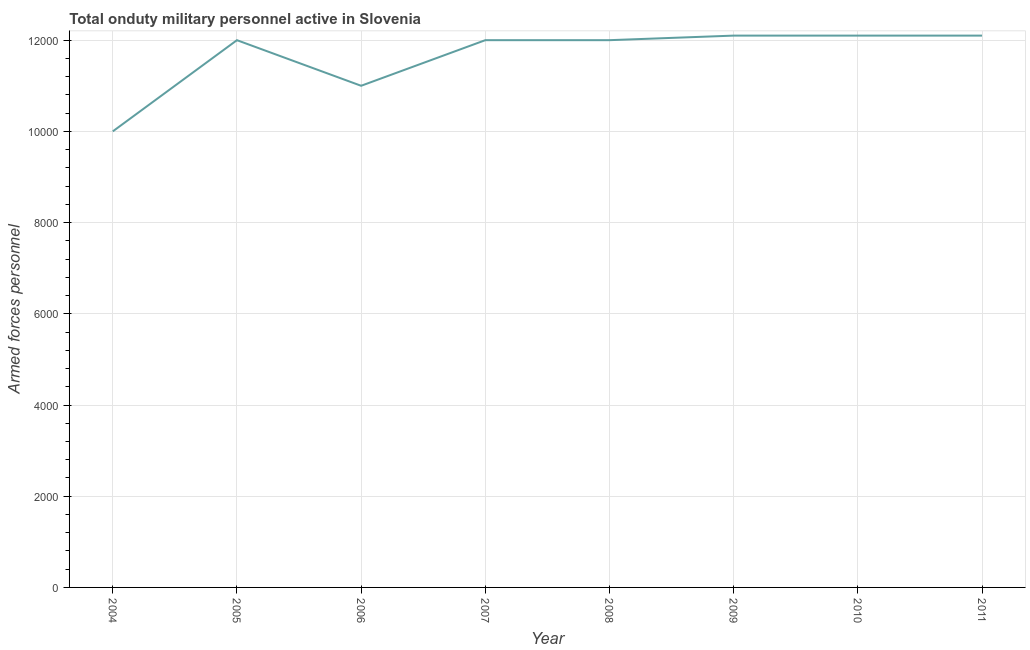What is the number of armed forces personnel in 2010?
Make the answer very short. 1.21e+04. Across all years, what is the maximum number of armed forces personnel?
Offer a very short reply. 1.21e+04. Across all years, what is the minimum number of armed forces personnel?
Provide a succinct answer. 10000. What is the sum of the number of armed forces personnel?
Make the answer very short. 9.33e+04. What is the difference between the number of armed forces personnel in 2005 and 2010?
Keep it short and to the point. -100. What is the average number of armed forces personnel per year?
Ensure brevity in your answer.  1.17e+04. What is the median number of armed forces personnel?
Your answer should be very brief. 1.20e+04. In how many years, is the number of armed forces personnel greater than 800 ?
Provide a short and direct response. 8. Do a majority of the years between 2007 and 2008 (inclusive) have number of armed forces personnel greater than 11600 ?
Keep it short and to the point. Yes. What is the ratio of the number of armed forces personnel in 2007 to that in 2009?
Your response must be concise. 0.99. What is the difference between the highest and the second highest number of armed forces personnel?
Ensure brevity in your answer.  0. Is the sum of the number of armed forces personnel in 2006 and 2011 greater than the maximum number of armed forces personnel across all years?
Your answer should be compact. Yes. What is the difference between the highest and the lowest number of armed forces personnel?
Ensure brevity in your answer.  2100. Does the number of armed forces personnel monotonically increase over the years?
Provide a short and direct response. No. How many lines are there?
Your answer should be compact. 1. What is the difference between two consecutive major ticks on the Y-axis?
Make the answer very short. 2000. Are the values on the major ticks of Y-axis written in scientific E-notation?
Make the answer very short. No. What is the title of the graph?
Your response must be concise. Total onduty military personnel active in Slovenia. What is the label or title of the X-axis?
Provide a succinct answer. Year. What is the label or title of the Y-axis?
Ensure brevity in your answer.  Armed forces personnel. What is the Armed forces personnel in 2005?
Make the answer very short. 1.20e+04. What is the Armed forces personnel of 2006?
Offer a terse response. 1.10e+04. What is the Armed forces personnel in 2007?
Keep it short and to the point. 1.20e+04. What is the Armed forces personnel of 2008?
Offer a terse response. 1.20e+04. What is the Armed forces personnel of 2009?
Your answer should be compact. 1.21e+04. What is the Armed forces personnel in 2010?
Your answer should be compact. 1.21e+04. What is the Armed forces personnel of 2011?
Give a very brief answer. 1.21e+04. What is the difference between the Armed forces personnel in 2004 and 2005?
Offer a very short reply. -2000. What is the difference between the Armed forces personnel in 2004 and 2006?
Give a very brief answer. -1000. What is the difference between the Armed forces personnel in 2004 and 2007?
Give a very brief answer. -2000. What is the difference between the Armed forces personnel in 2004 and 2008?
Provide a short and direct response. -2000. What is the difference between the Armed forces personnel in 2004 and 2009?
Your answer should be compact. -2100. What is the difference between the Armed forces personnel in 2004 and 2010?
Make the answer very short. -2100. What is the difference between the Armed forces personnel in 2004 and 2011?
Ensure brevity in your answer.  -2100. What is the difference between the Armed forces personnel in 2005 and 2008?
Offer a very short reply. 0. What is the difference between the Armed forces personnel in 2005 and 2009?
Your answer should be very brief. -100. What is the difference between the Armed forces personnel in 2005 and 2010?
Your answer should be compact. -100. What is the difference between the Armed forces personnel in 2005 and 2011?
Provide a succinct answer. -100. What is the difference between the Armed forces personnel in 2006 and 2007?
Offer a very short reply. -1000. What is the difference between the Armed forces personnel in 2006 and 2008?
Ensure brevity in your answer.  -1000. What is the difference between the Armed forces personnel in 2006 and 2009?
Give a very brief answer. -1100. What is the difference between the Armed forces personnel in 2006 and 2010?
Your response must be concise. -1100. What is the difference between the Armed forces personnel in 2006 and 2011?
Your answer should be compact. -1100. What is the difference between the Armed forces personnel in 2007 and 2009?
Offer a very short reply. -100. What is the difference between the Armed forces personnel in 2007 and 2010?
Offer a very short reply. -100. What is the difference between the Armed forces personnel in 2007 and 2011?
Your answer should be compact. -100. What is the difference between the Armed forces personnel in 2008 and 2009?
Provide a succinct answer. -100. What is the difference between the Armed forces personnel in 2008 and 2010?
Your answer should be compact. -100. What is the difference between the Armed forces personnel in 2008 and 2011?
Keep it short and to the point. -100. What is the difference between the Armed forces personnel in 2009 and 2010?
Offer a terse response. 0. What is the difference between the Armed forces personnel in 2009 and 2011?
Provide a succinct answer. 0. What is the difference between the Armed forces personnel in 2010 and 2011?
Provide a short and direct response. 0. What is the ratio of the Armed forces personnel in 2004 to that in 2005?
Keep it short and to the point. 0.83. What is the ratio of the Armed forces personnel in 2004 to that in 2006?
Offer a very short reply. 0.91. What is the ratio of the Armed forces personnel in 2004 to that in 2007?
Your answer should be very brief. 0.83. What is the ratio of the Armed forces personnel in 2004 to that in 2008?
Keep it short and to the point. 0.83. What is the ratio of the Armed forces personnel in 2004 to that in 2009?
Provide a succinct answer. 0.83. What is the ratio of the Armed forces personnel in 2004 to that in 2010?
Provide a succinct answer. 0.83. What is the ratio of the Armed forces personnel in 2004 to that in 2011?
Offer a terse response. 0.83. What is the ratio of the Armed forces personnel in 2005 to that in 2006?
Offer a terse response. 1.09. What is the ratio of the Armed forces personnel in 2005 to that in 2007?
Your response must be concise. 1. What is the ratio of the Armed forces personnel in 2005 to that in 2011?
Your answer should be very brief. 0.99. What is the ratio of the Armed forces personnel in 2006 to that in 2007?
Offer a very short reply. 0.92. What is the ratio of the Armed forces personnel in 2006 to that in 2008?
Ensure brevity in your answer.  0.92. What is the ratio of the Armed forces personnel in 2006 to that in 2009?
Provide a succinct answer. 0.91. What is the ratio of the Armed forces personnel in 2006 to that in 2010?
Give a very brief answer. 0.91. What is the ratio of the Armed forces personnel in 2006 to that in 2011?
Provide a short and direct response. 0.91. What is the ratio of the Armed forces personnel in 2007 to that in 2011?
Ensure brevity in your answer.  0.99. What is the ratio of the Armed forces personnel in 2008 to that in 2010?
Offer a very short reply. 0.99. What is the ratio of the Armed forces personnel in 2010 to that in 2011?
Give a very brief answer. 1. 